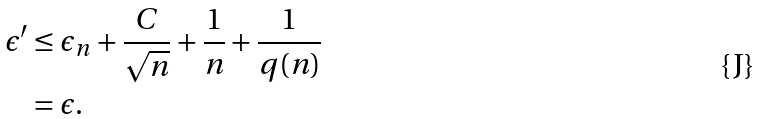<formula> <loc_0><loc_0><loc_500><loc_500>\epsilon ^ { \prime } & \leq \epsilon _ { n } + \frac { C } { \sqrt { n } } + \frac { 1 } { n } + \frac { 1 } { q ( n ) } \\ & = \epsilon .</formula> 